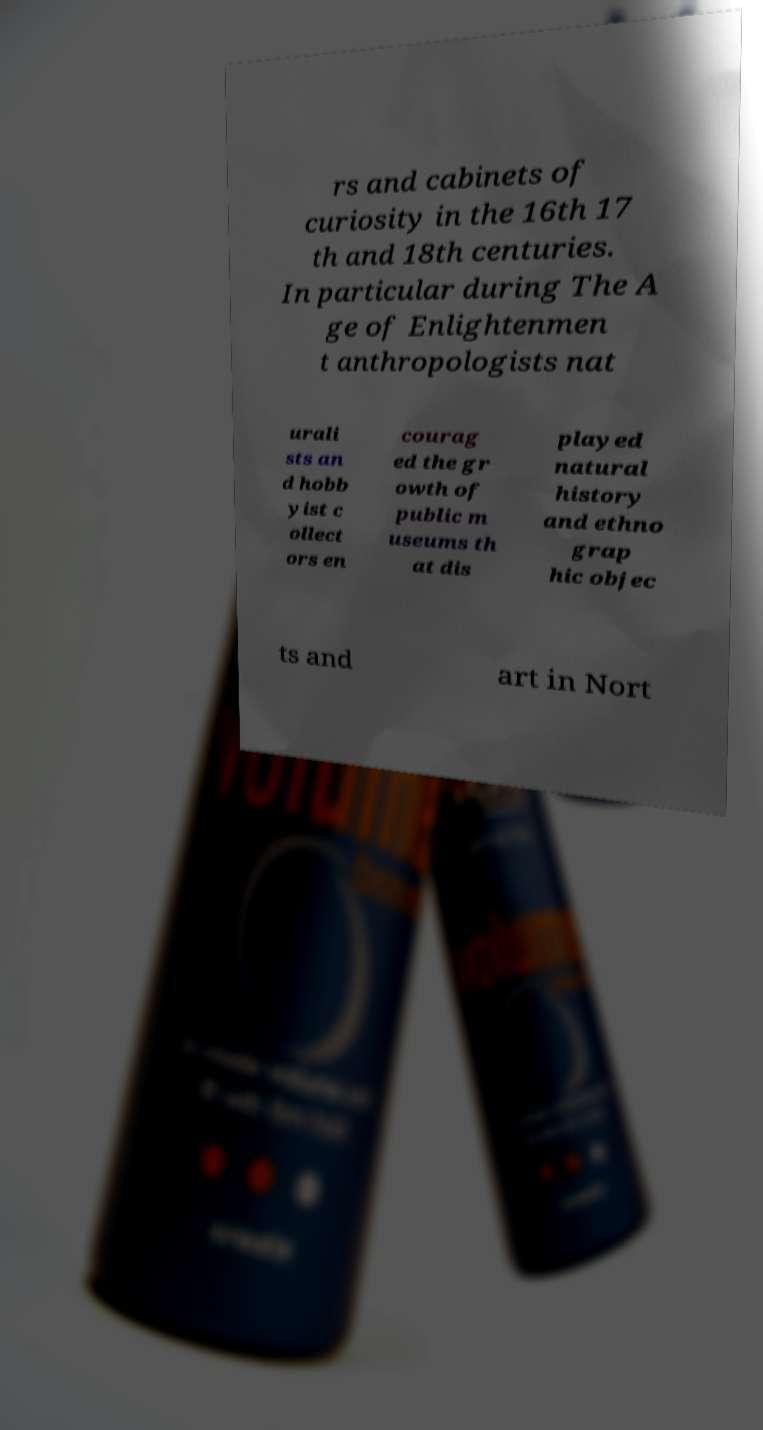Could you extract and type out the text from this image? rs and cabinets of curiosity in the 16th 17 th and 18th centuries. In particular during The A ge of Enlightenmen t anthropologists nat urali sts an d hobb yist c ollect ors en courag ed the gr owth of public m useums th at dis played natural history and ethno grap hic objec ts and art in Nort 